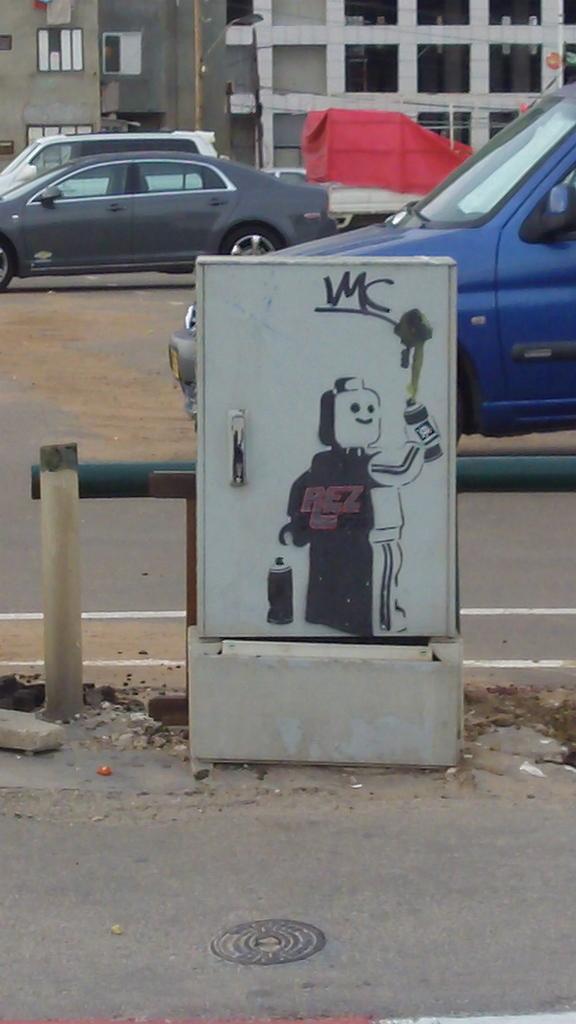In one or two sentences, can you explain what this image depicts? In this image I see the white box on which there is an art and I see the path and I see few cars. In the background I see the buildings and I see the red color cloth over here. 